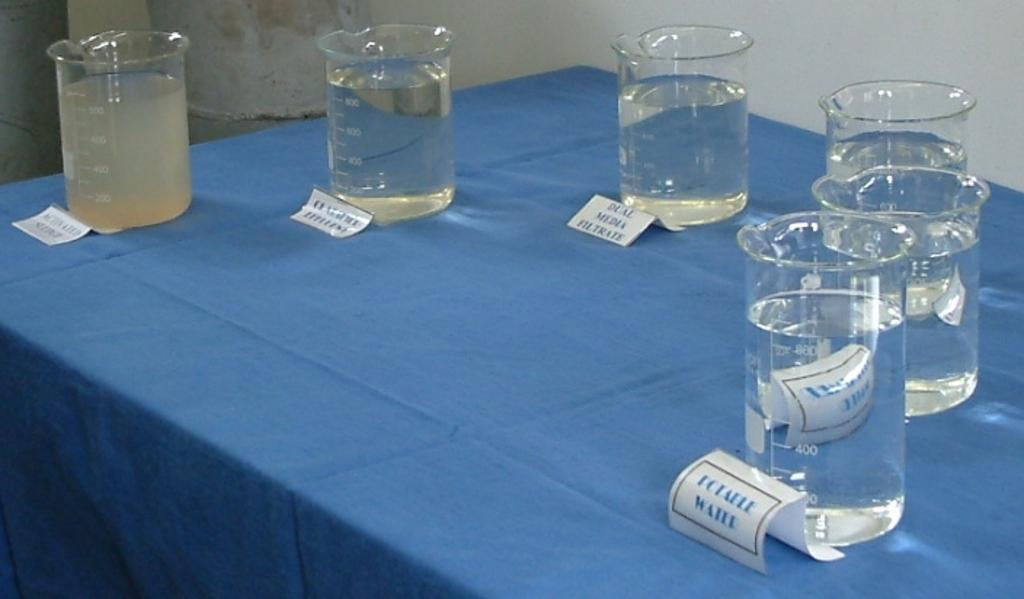What is written on those labels?
Provide a short and direct response. Water. 